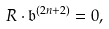<formula> <loc_0><loc_0><loc_500><loc_500>R \cdot { \mathfrak b } ^ { ( 2 n + 2 ) } = 0 ,</formula> 